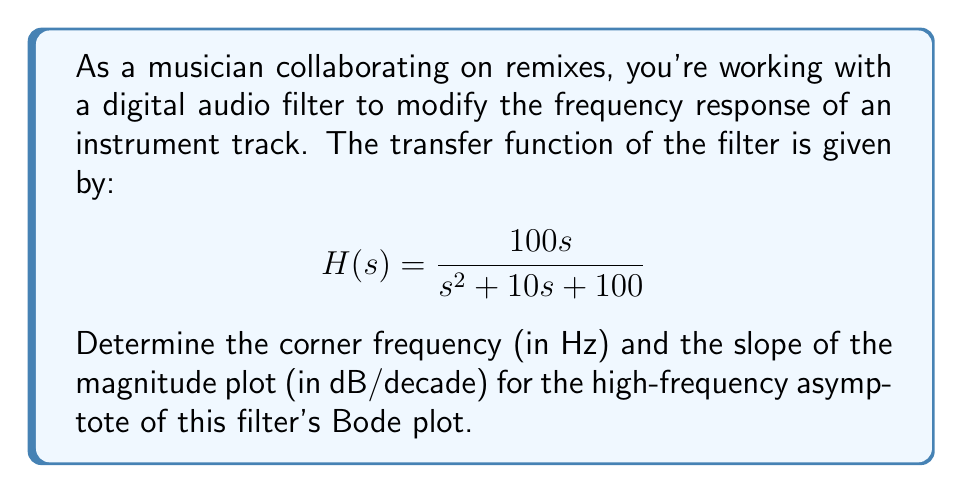Provide a solution to this math problem. To analyze the frequency response using Bode plots, we'll follow these steps:

1) First, let's identify the general form of the transfer function:
   $$H(s) = K \frac{s}{s^2 + 2\zeta\omega_n s + \omega_n^2}$$

   Where $K$ is the gain, $\zeta$ is the damping ratio, and $\omega_n$ is the natural frequency.

2) Comparing our given function to this form:
   $$H(s) = \frac{100s}{s^2 + 10s + 100}$$

   We can see that $K = 100$, $2\zeta\omega_n = 10$, and $\omega_n^2 = 100$.

3) From $\omega_n^2 = 100$, we can determine $\omega_n$:
   $$\omega_n = \sqrt{100} = 10 \text{ rad/s}$$

4) The corner frequency, also known as the natural frequency, is $\omega_n$. To convert from rad/s to Hz, we use:
   $$f_n = \frac{\omega_n}{2\pi} = \frac{10}{2\pi} \approx 1.59 \text{ Hz}$$

5) For the high-frequency asymptote, we look at the behavior as $s \to \infty$:
   $$\lim_{s \to \infty} H(s) = \lim_{s \to \infty} \frac{100s}{s^2 + 10s + 100} = \lim_{s \to \infty} \frac{100}{s}$$

6) This indicates that for high frequencies, the magnitude decreases at a rate of -20 dB/decade (because $s$ is in the denominator with a power of 1).

Therefore, the corner frequency is approximately 1.59 Hz, and the slope of the magnitude plot for the high-frequency asymptote is -20 dB/decade.
Answer: Corner frequency: 1.59 Hz
Slope of high-frequency asymptote: -20 dB/decade 